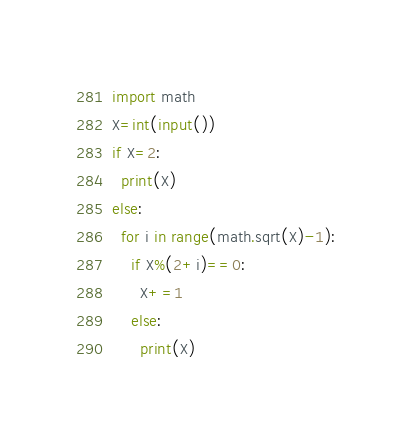<code> <loc_0><loc_0><loc_500><loc_500><_Python_>import math
X=int(input())
if X=2:
  print(X)
else:
  for i in range(math.sqrt(X)-1):
    if X%(2+i)==0:
      X+=1
    else:
      print(X)</code> 